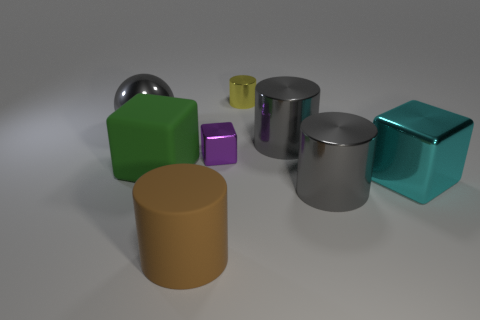Subtract 1 cylinders. How many cylinders are left? 3 Add 2 small objects. How many objects exist? 10 Subtract all spheres. How many objects are left? 7 Subtract all large brown metallic balls. Subtract all large cyan things. How many objects are left? 7 Add 6 large metal cylinders. How many large metal cylinders are left? 8 Add 3 spheres. How many spheres exist? 4 Subtract 0 purple cylinders. How many objects are left? 8 